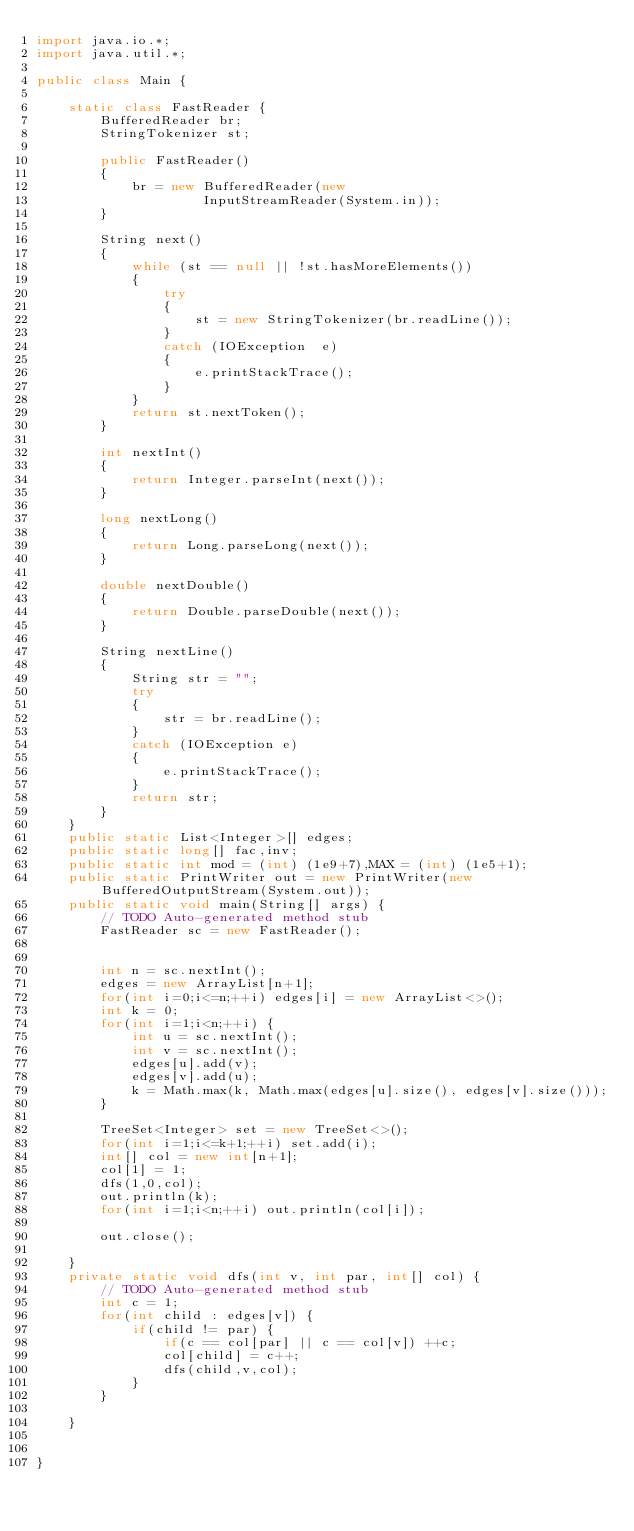<code> <loc_0><loc_0><loc_500><loc_500><_Java_>import java.io.*;
import java.util.*;

public class Main {

	static class FastReader { 
        BufferedReader br; 
        StringTokenizer st; 
  
        public FastReader() 
        { 
            br = new BufferedReader(new
                     InputStreamReader(System.in)); 
        } 
  
        String next() 
        { 
            while (st == null || !st.hasMoreElements()) 
            { 
                try
                { 
                    st = new StringTokenizer(br.readLine()); 
                } 
                catch (IOException  e) 
                { 
                    e.printStackTrace(); 
                } 
            } 
            return st.nextToken(); 
        } 
  
        int nextInt() 
        { 
            return Integer.parseInt(next()); 
        } 
  
        long nextLong() 
        { 
            return Long.parseLong(next()); 
        } 
  
        double nextDouble() 
        { 
            return Double.parseDouble(next()); 
        } 
  
        String nextLine() 
        { 
            String str = ""; 
            try
            { 
                str = br.readLine(); 
            } 
            catch (IOException e) 
            { 
                e.printStackTrace(); 
            } 
            return str; 
        } 
    } 
	public static List<Integer>[] edges;
	public static long[] fac,inv;
	public static int mod = (int) (1e9+7),MAX = (int) (1e5+1);
	public static PrintWriter out = new PrintWriter(new BufferedOutputStream(System.out));
	public static void main(String[] args) {
		// TODO Auto-generated method stub
		FastReader sc = new FastReader();
	
	
		int n = sc.nextInt();
		edges = new ArrayList[n+1];
		for(int i=0;i<=n;++i) edges[i] = new ArrayList<>();
		int k = 0;
		for(int i=1;i<n;++i) {
			int u = sc.nextInt();
			int v = sc.nextInt();
			edges[u].add(v);
			edges[v].add(u);
			k = Math.max(k, Math.max(edges[u].size(), edges[v].size()));
		}
		
		TreeSet<Integer> set = new TreeSet<>();
		for(int i=1;i<=k+1;++i) set.add(i);
		int[] col = new int[n+1]; 
		col[1] = 1;
		dfs(1,0,col);
		out.println(k);
		for(int i=1;i<n;++i) out.println(col[i]);
		
        out.close();
		
	}
	private static void dfs(int v, int par, int[] col) {
		// TODO Auto-generated method stub
		int c = 1;
		for(int child : edges[v]) {
			if(child != par) {
				if(c == col[par] || c == col[v]) ++c;
				col[child] = c++;
				dfs(child,v,col);
			}
		}
		
	}

	
}
</code> 